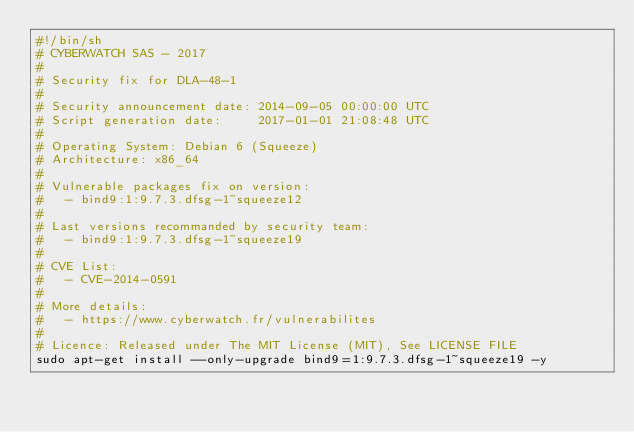<code> <loc_0><loc_0><loc_500><loc_500><_Bash_>#!/bin/sh
# CYBERWATCH SAS - 2017
#
# Security fix for DLA-48-1
#
# Security announcement date: 2014-09-05 00:00:00 UTC
# Script generation date:     2017-01-01 21:08:48 UTC
#
# Operating System: Debian 6 (Squeeze)
# Architecture: x86_64
#
# Vulnerable packages fix on version:
#   - bind9:1:9.7.3.dfsg-1~squeeze12
#
# Last versions recommanded by security team:
#   - bind9:1:9.7.3.dfsg-1~squeeze19
#
# CVE List:
#   - CVE-2014-0591
#
# More details:
#   - https://www.cyberwatch.fr/vulnerabilites
#
# Licence: Released under The MIT License (MIT), See LICENSE FILE
sudo apt-get install --only-upgrade bind9=1:9.7.3.dfsg-1~squeeze19 -y
</code> 